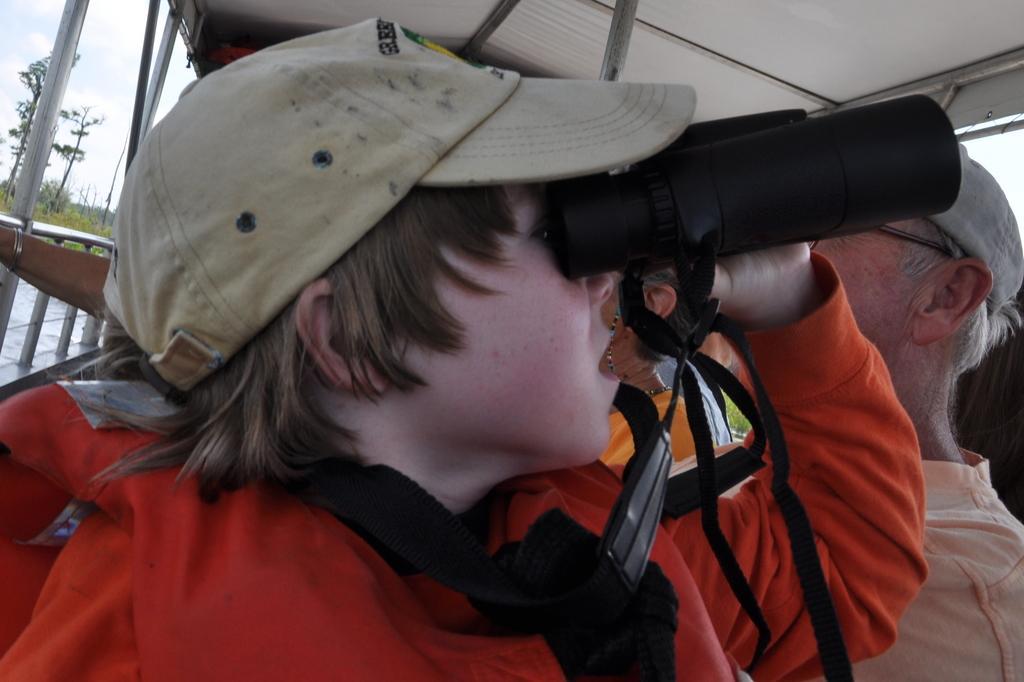Can you describe this image briefly? In this image, we can see a child holding binocular and his is wearing a cap. In the background, there are trees and we can see some other people. At the top, there is rood. 